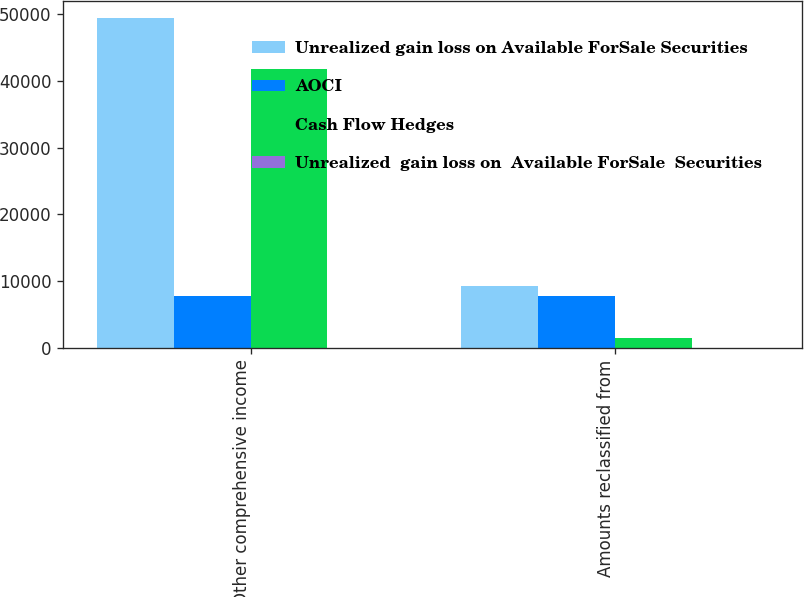Convert chart. <chart><loc_0><loc_0><loc_500><loc_500><stacked_bar_chart><ecel><fcel>Other comprehensive income<fcel>Amounts reclassified from<nl><fcel>Unrealized gain loss on Available ForSale Securities<fcel>49524<fcel>9180<nl><fcel>AOCI<fcel>7752<fcel>7752<nl><fcel>Cash Flow Hedges<fcel>41772<fcel>1428<nl><fcel>Unrealized  gain loss on  Available ForSale  Securities<fcel>13<fcel>13<nl></chart> 